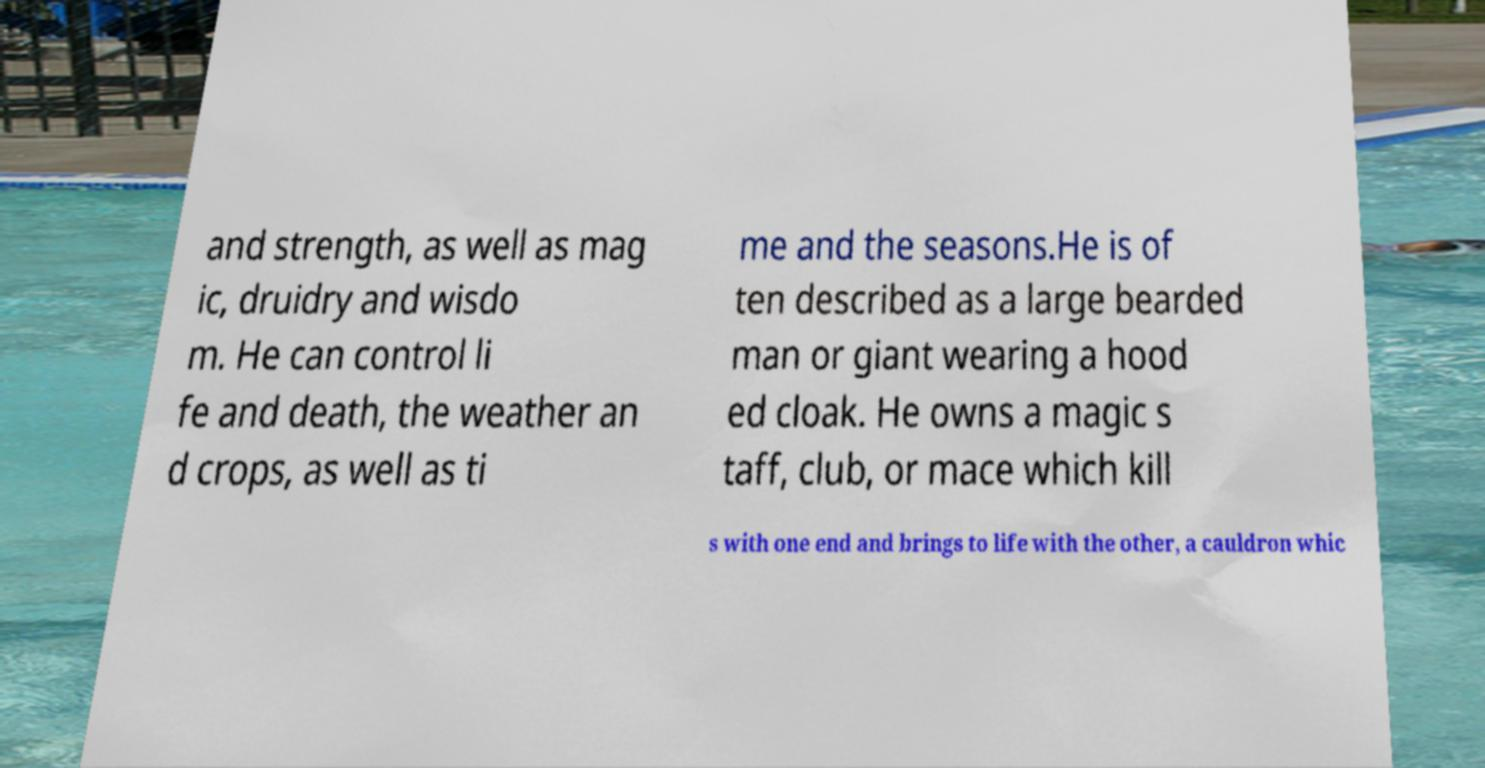Can you read and provide the text displayed in the image?This photo seems to have some interesting text. Can you extract and type it out for me? and strength, as well as mag ic, druidry and wisdo m. He can control li fe and death, the weather an d crops, as well as ti me and the seasons.He is of ten described as a large bearded man or giant wearing a hood ed cloak. He owns a magic s taff, club, or mace which kill s with one end and brings to life with the other, a cauldron whic 